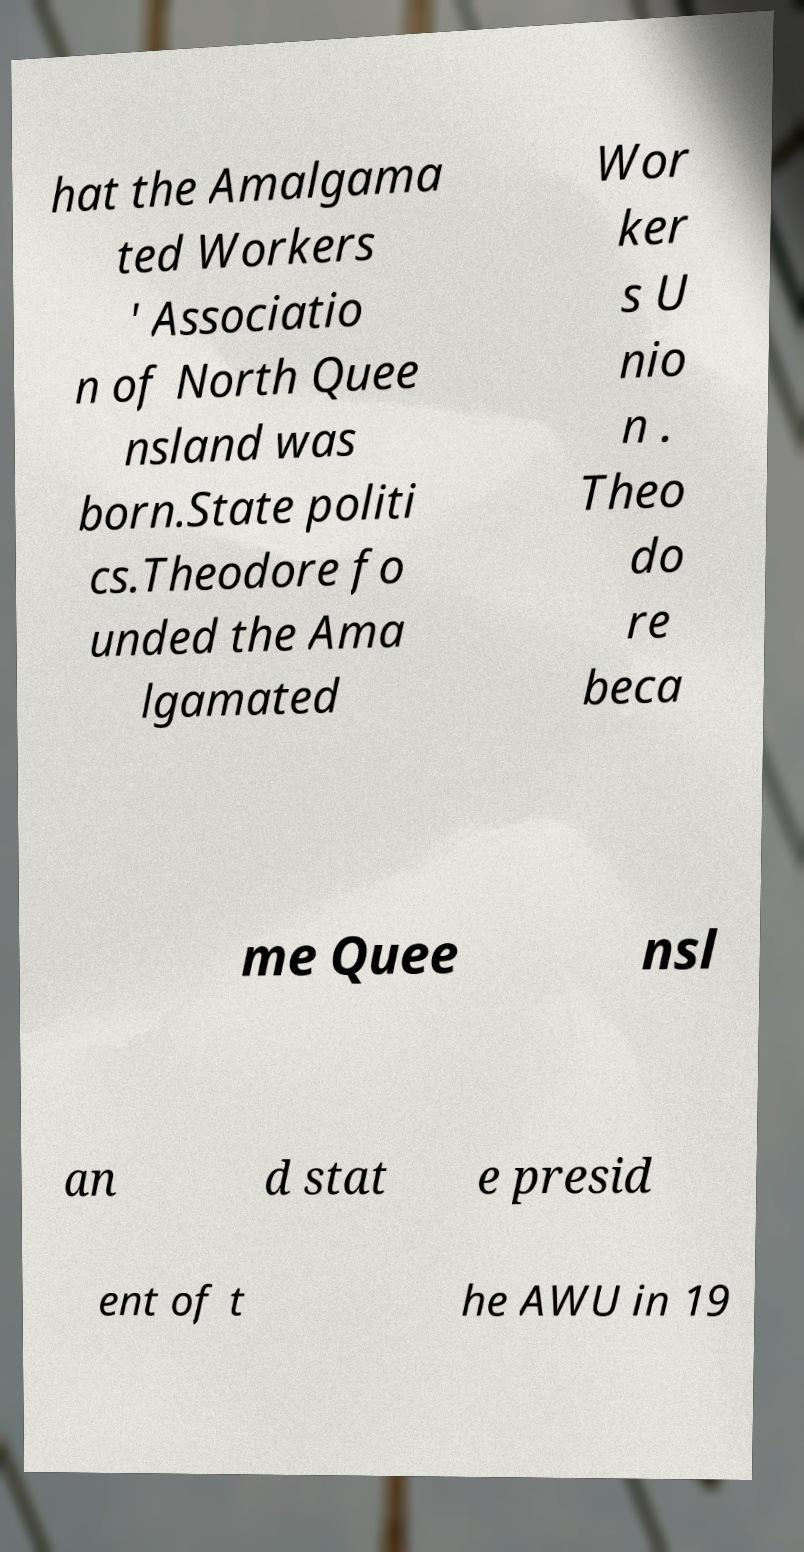What messages or text are displayed in this image? I need them in a readable, typed format. hat the Amalgama ted Workers ' Associatio n of North Quee nsland was born.State politi cs.Theodore fo unded the Ama lgamated Wor ker s U nio n . Theo do re beca me Quee nsl an d stat e presid ent of t he AWU in 19 